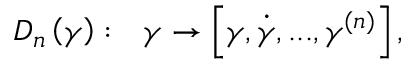<formula> <loc_0><loc_0><loc_500><loc_500>D _ { n } \left ( \gamma \right ) \colon \ \gamma \rightarrow \left [ \gamma , \dot { \gamma } , \dots , \gamma ^ { ( n ) } \right ] ,</formula> 